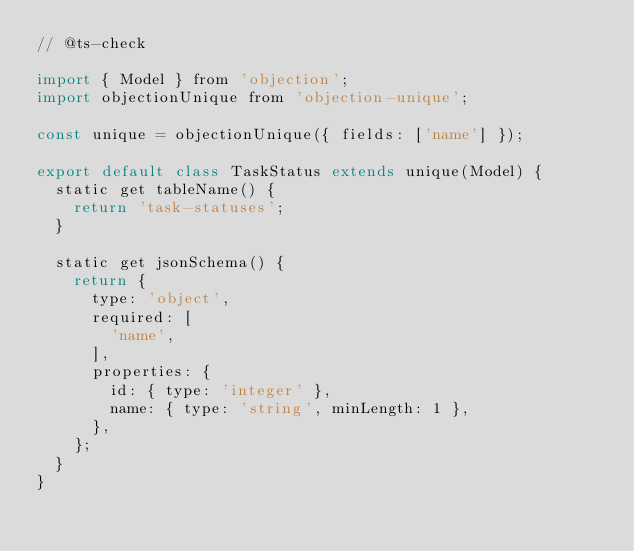Convert code to text. <code><loc_0><loc_0><loc_500><loc_500><_JavaScript_>// @ts-check

import { Model } from 'objection';
import objectionUnique from 'objection-unique';

const unique = objectionUnique({ fields: ['name'] });

export default class TaskStatus extends unique(Model) {
  static get tableName() {
    return 'task-statuses';
  }

  static get jsonSchema() {
    return {
      type: 'object',
      required: [
        'name',
      ],
      properties: {
        id: { type: 'integer' },
        name: { type: 'string', minLength: 1 },
      },
    };
  }
}
</code> 